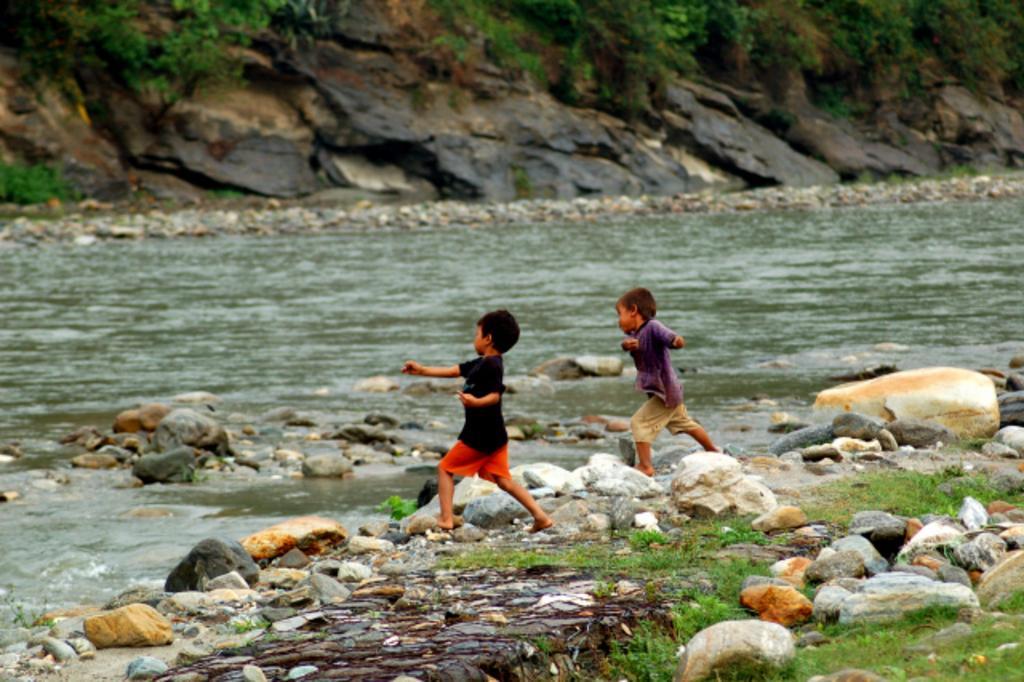Could you give a brief overview of what you see in this image? This picture is clicked outside the city. In the foreground we can see the green grass and the rocks. In the center there are two kids running on the ground and there is a water body. In the background we can see the plants and the rocks. 